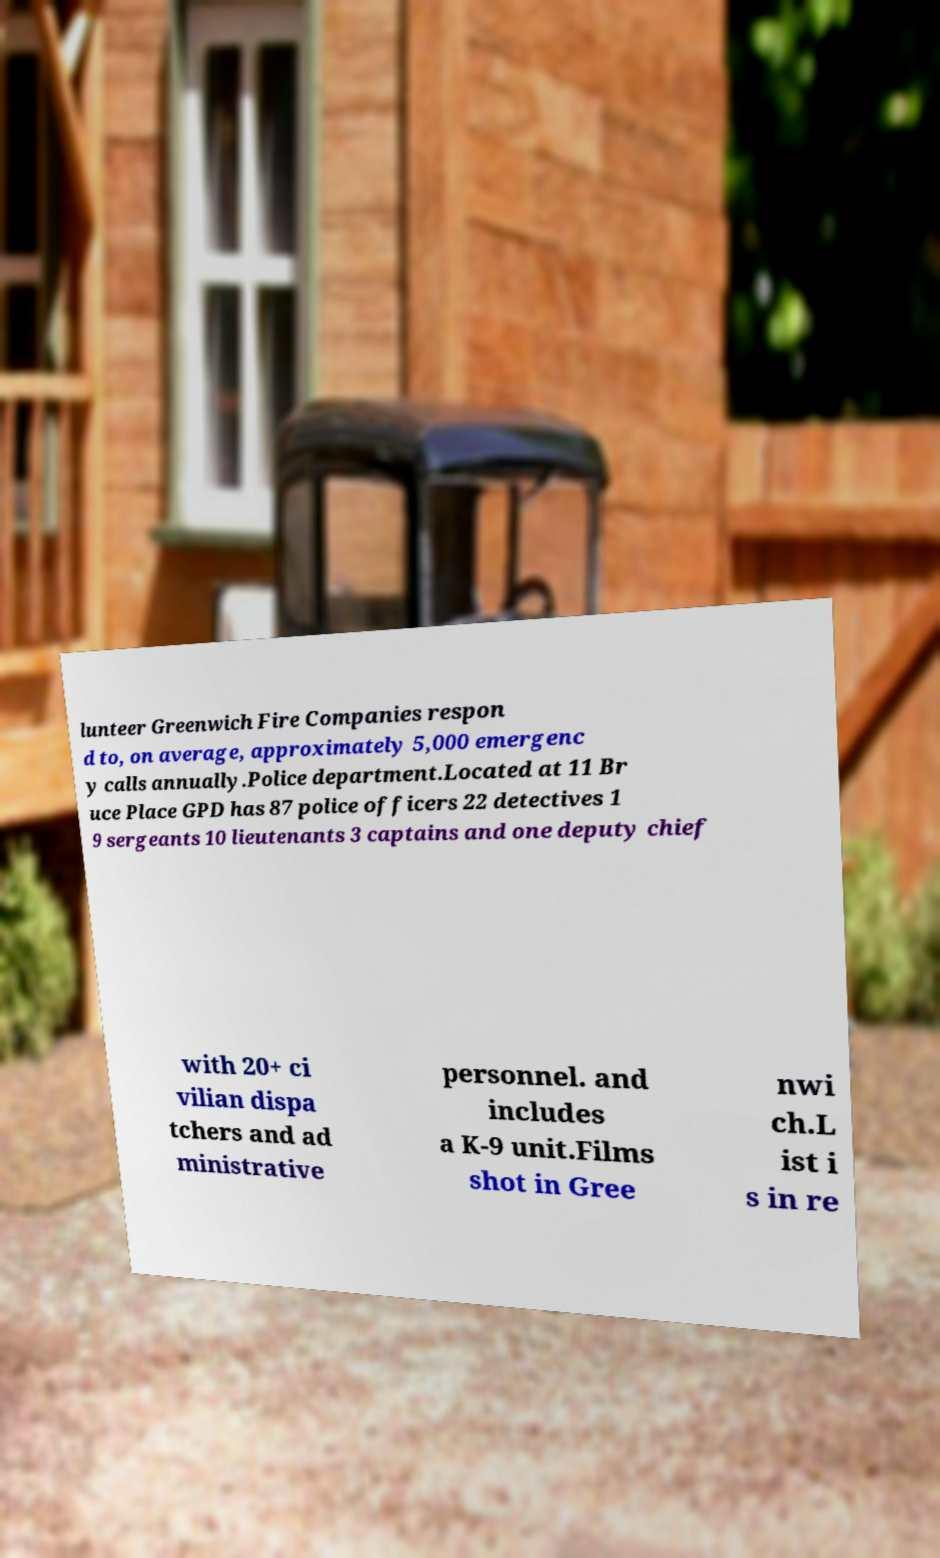There's text embedded in this image that I need extracted. Can you transcribe it verbatim? lunteer Greenwich Fire Companies respon d to, on average, approximately 5,000 emergenc y calls annually.Police department.Located at 11 Br uce Place GPD has 87 police officers 22 detectives 1 9 sergeants 10 lieutenants 3 captains and one deputy chief with 20+ ci vilian dispa tchers and ad ministrative personnel. and includes a K-9 unit.Films shot in Gree nwi ch.L ist i s in re 